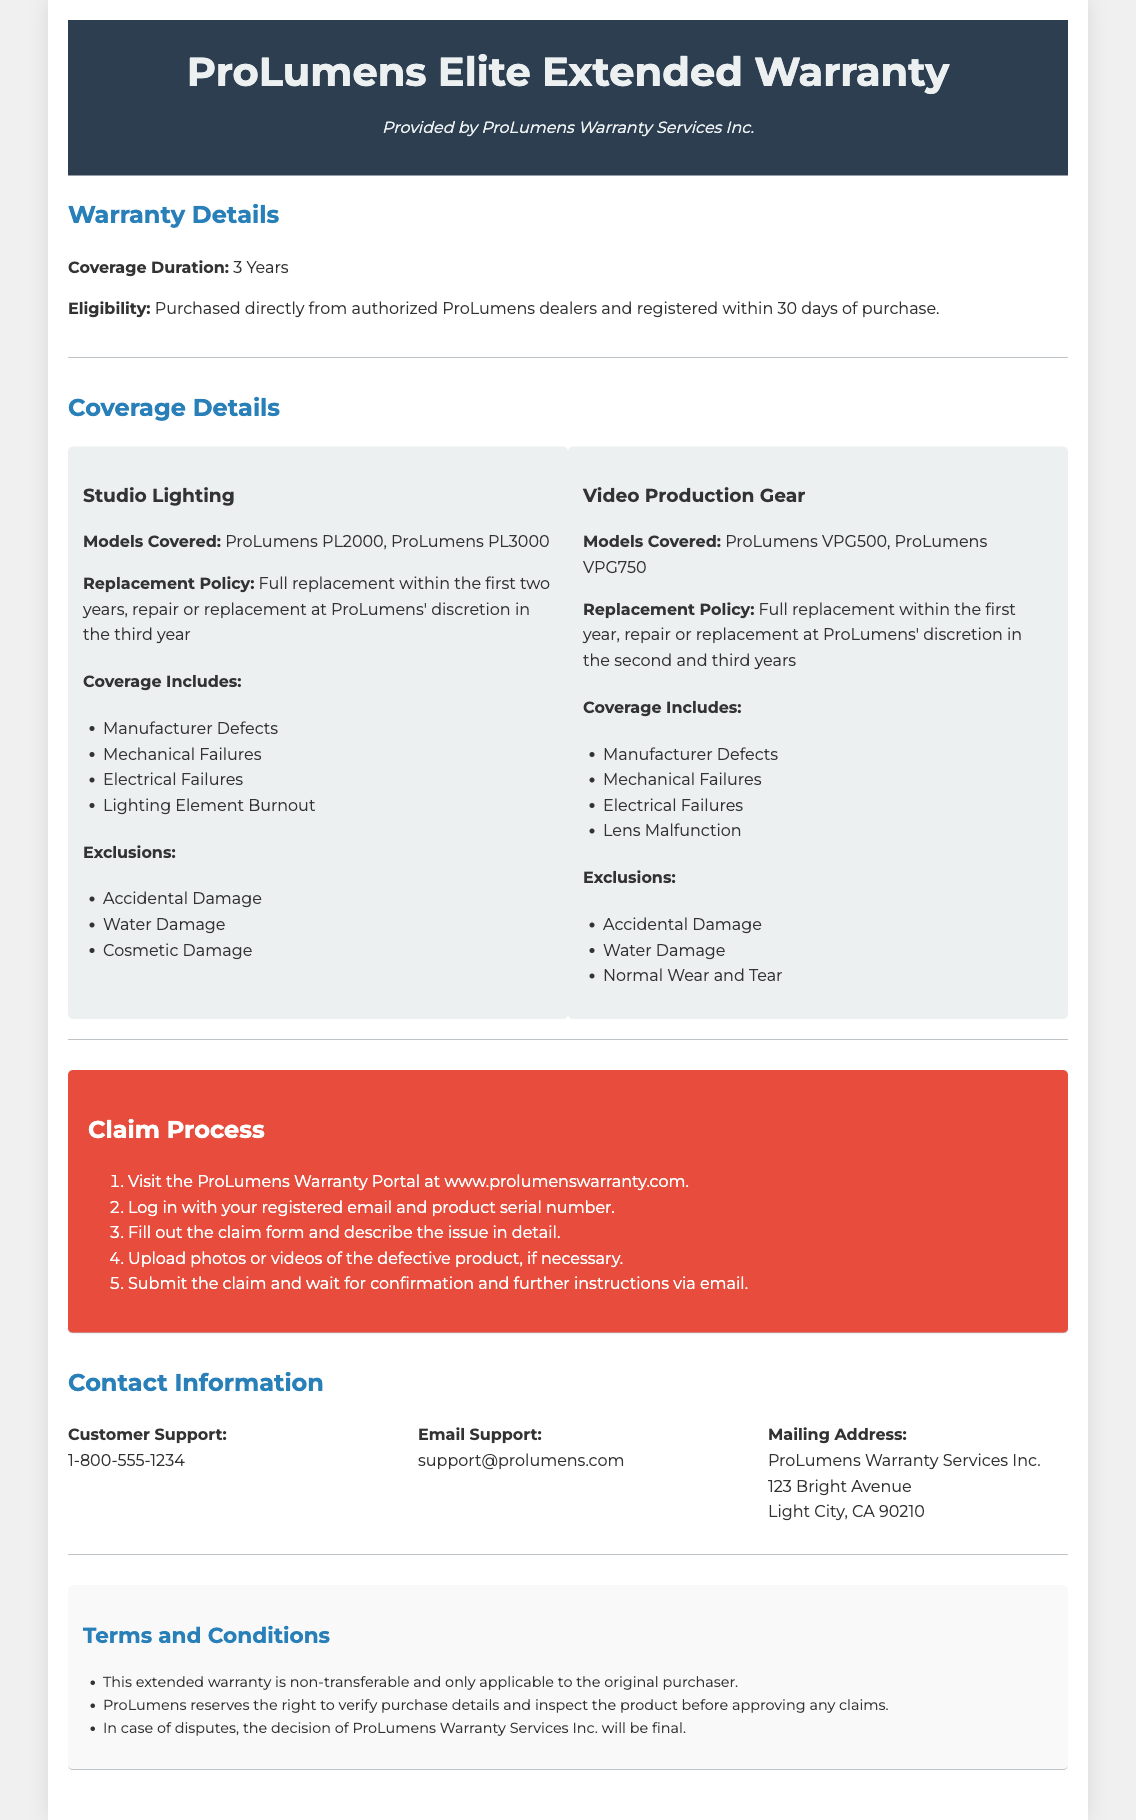What is the coverage duration? The coverage duration is specified in the warranty details section of the document.
Answer: 3 Years What models are covered under Studio Lighting? This information is found in the coverage details section mentioning the specific models.
Answer: ProLumens PL2000, ProLumens PL3000 What is the replacement policy for Video Production Gear? The replacement policy is detailed in the coverage section for video production gear.
Answer: Full replacement within the first year, repair or replacement at ProLumens' discretion in the second and third years Which types of failures are included in the coverage? The document lists the types of failures that are included in the coverage of both studio lighting and video production gear.
Answer: Manufacturer Defects, Mechanical Failures, Electrical Failures What is the process to start a warranty claim? The claim process is outlined in a specific section in a step-by-step manner.
Answer: Visit the ProLumens Warranty Portal What must you do to be eligible for the warranty? The eligibility criteria are mentioned in the warranty details section.
Answer: Purchased directly from authorized ProLumens dealers and registered within 30 days of purchase What type of damage is excluded from the warranty? Exclusions are specifically listed in the coverage details for both studio lighting and video production gear.
Answer: Accidental Damage What is the phone number for customer support? The contact information section provides specific contact details for customer support.
Answer: 1-800-555-1234 